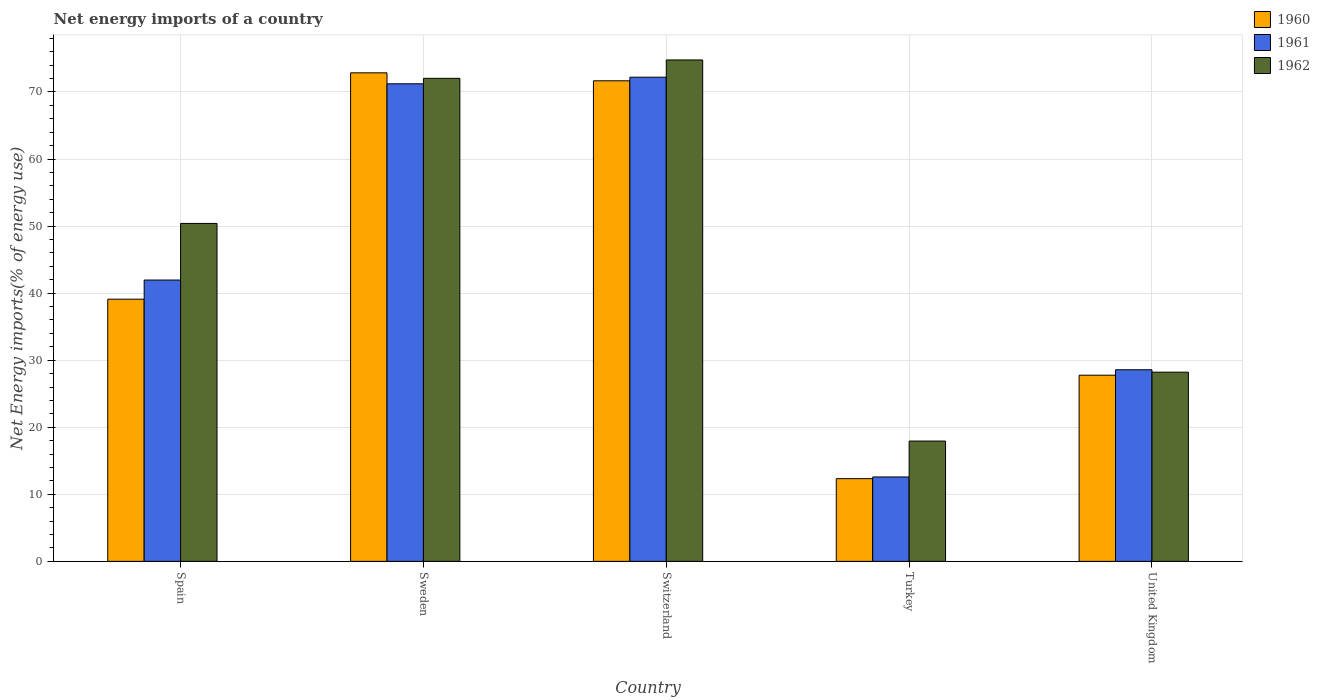Are the number of bars per tick equal to the number of legend labels?
Offer a very short reply. Yes. Are the number of bars on each tick of the X-axis equal?
Offer a very short reply. Yes. How many bars are there on the 3rd tick from the left?
Provide a succinct answer. 3. How many bars are there on the 5th tick from the right?
Give a very brief answer. 3. In how many cases, is the number of bars for a given country not equal to the number of legend labels?
Ensure brevity in your answer.  0. What is the net energy imports in 1961 in Sweden?
Your answer should be compact. 71.22. Across all countries, what is the maximum net energy imports in 1962?
Provide a short and direct response. 74.78. Across all countries, what is the minimum net energy imports in 1961?
Give a very brief answer. 12.59. In which country was the net energy imports in 1962 minimum?
Keep it short and to the point. Turkey. What is the total net energy imports in 1961 in the graph?
Your response must be concise. 226.55. What is the difference between the net energy imports in 1960 in Spain and that in Sweden?
Keep it short and to the point. -33.76. What is the difference between the net energy imports in 1962 in Sweden and the net energy imports in 1961 in Spain?
Your response must be concise. 30.08. What is the average net energy imports in 1961 per country?
Provide a succinct answer. 45.31. What is the difference between the net energy imports of/in 1961 and net energy imports of/in 1960 in United Kingdom?
Offer a terse response. 0.81. What is the ratio of the net energy imports in 1961 in Spain to that in Sweden?
Your answer should be compact. 0.59. What is the difference between the highest and the second highest net energy imports in 1960?
Provide a short and direct response. 33.76. What is the difference between the highest and the lowest net energy imports in 1961?
Your answer should be very brief. 59.62. In how many countries, is the net energy imports in 1960 greater than the average net energy imports in 1960 taken over all countries?
Make the answer very short. 2. How many bars are there?
Keep it short and to the point. 15. How many countries are there in the graph?
Your answer should be compact. 5. How are the legend labels stacked?
Provide a short and direct response. Vertical. What is the title of the graph?
Offer a terse response. Net energy imports of a country. What is the label or title of the X-axis?
Provide a short and direct response. Country. What is the label or title of the Y-axis?
Offer a very short reply. Net Energy imports(% of energy use). What is the Net Energy imports(% of energy use) in 1960 in Spain?
Offer a terse response. 39.1. What is the Net Energy imports(% of energy use) of 1961 in Spain?
Give a very brief answer. 41.95. What is the Net Energy imports(% of energy use) in 1962 in Spain?
Keep it short and to the point. 50.4. What is the Net Energy imports(% of energy use) of 1960 in Sweden?
Your answer should be very brief. 72.86. What is the Net Energy imports(% of energy use) of 1961 in Sweden?
Your response must be concise. 71.22. What is the Net Energy imports(% of energy use) in 1962 in Sweden?
Keep it short and to the point. 72.04. What is the Net Energy imports(% of energy use) in 1960 in Switzerland?
Give a very brief answer. 71.67. What is the Net Energy imports(% of energy use) in 1961 in Switzerland?
Offer a terse response. 72.21. What is the Net Energy imports(% of energy use) in 1962 in Switzerland?
Make the answer very short. 74.78. What is the Net Energy imports(% of energy use) of 1960 in Turkey?
Offer a terse response. 12.34. What is the Net Energy imports(% of energy use) of 1961 in Turkey?
Make the answer very short. 12.59. What is the Net Energy imports(% of energy use) in 1962 in Turkey?
Offer a very short reply. 17.94. What is the Net Energy imports(% of energy use) in 1960 in United Kingdom?
Keep it short and to the point. 27.76. What is the Net Energy imports(% of energy use) in 1961 in United Kingdom?
Ensure brevity in your answer.  28.58. What is the Net Energy imports(% of energy use) of 1962 in United Kingdom?
Give a very brief answer. 28.22. Across all countries, what is the maximum Net Energy imports(% of energy use) of 1960?
Ensure brevity in your answer.  72.86. Across all countries, what is the maximum Net Energy imports(% of energy use) of 1961?
Ensure brevity in your answer.  72.21. Across all countries, what is the maximum Net Energy imports(% of energy use) of 1962?
Provide a short and direct response. 74.78. Across all countries, what is the minimum Net Energy imports(% of energy use) in 1960?
Your answer should be very brief. 12.34. Across all countries, what is the minimum Net Energy imports(% of energy use) of 1961?
Give a very brief answer. 12.59. Across all countries, what is the minimum Net Energy imports(% of energy use) of 1962?
Make the answer very short. 17.94. What is the total Net Energy imports(% of energy use) of 1960 in the graph?
Give a very brief answer. 223.72. What is the total Net Energy imports(% of energy use) in 1961 in the graph?
Your answer should be compact. 226.55. What is the total Net Energy imports(% of energy use) in 1962 in the graph?
Ensure brevity in your answer.  243.37. What is the difference between the Net Energy imports(% of energy use) of 1960 in Spain and that in Sweden?
Your response must be concise. -33.76. What is the difference between the Net Energy imports(% of energy use) of 1961 in Spain and that in Sweden?
Keep it short and to the point. -29.27. What is the difference between the Net Energy imports(% of energy use) in 1962 in Spain and that in Sweden?
Your answer should be compact. -21.64. What is the difference between the Net Energy imports(% of energy use) of 1960 in Spain and that in Switzerland?
Your response must be concise. -32.57. What is the difference between the Net Energy imports(% of energy use) of 1961 in Spain and that in Switzerland?
Offer a very short reply. -30.25. What is the difference between the Net Energy imports(% of energy use) of 1962 in Spain and that in Switzerland?
Offer a terse response. -24.38. What is the difference between the Net Energy imports(% of energy use) of 1960 in Spain and that in Turkey?
Provide a short and direct response. 26.76. What is the difference between the Net Energy imports(% of energy use) in 1961 in Spain and that in Turkey?
Your answer should be compact. 29.37. What is the difference between the Net Energy imports(% of energy use) of 1962 in Spain and that in Turkey?
Offer a terse response. 32.46. What is the difference between the Net Energy imports(% of energy use) of 1960 in Spain and that in United Kingdom?
Your answer should be compact. 11.34. What is the difference between the Net Energy imports(% of energy use) of 1961 in Spain and that in United Kingdom?
Give a very brief answer. 13.38. What is the difference between the Net Energy imports(% of energy use) of 1962 in Spain and that in United Kingdom?
Make the answer very short. 22.18. What is the difference between the Net Energy imports(% of energy use) of 1960 in Sweden and that in Switzerland?
Provide a short and direct response. 1.19. What is the difference between the Net Energy imports(% of energy use) in 1961 in Sweden and that in Switzerland?
Offer a terse response. -0.98. What is the difference between the Net Energy imports(% of energy use) in 1962 in Sweden and that in Switzerland?
Offer a terse response. -2.74. What is the difference between the Net Energy imports(% of energy use) in 1960 in Sweden and that in Turkey?
Give a very brief answer. 60.52. What is the difference between the Net Energy imports(% of energy use) in 1961 in Sweden and that in Turkey?
Your response must be concise. 58.64. What is the difference between the Net Energy imports(% of energy use) of 1962 in Sweden and that in Turkey?
Your answer should be very brief. 54.1. What is the difference between the Net Energy imports(% of energy use) of 1960 in Sweden and that in United Kingdom?
Your response must be concise. 45.1. What is the difference between the Net Energy imports(% of energy use) of 1961 in Sweden and that in United Kingdom?
Offer a very short reply. 42.65. What is the difference between the Net Energy imports(% of energy use) in 1962 in Sweden and that in United Kingdom?
Keep it short and to the point. 43.82. What is the difference between the Net Energy imports(% of energy use) of 1960 in Switzerland and that in Turkey?
Provide a short and direct response. 59.33. What is the difference between the Net Energy imports(% of energy use) of 1961 in Switzerland and that in Turkey?
Provide a succinct answer. 59.62. What is the difference between the Net Energy imports(% of energy use) in 1962 in Switzerland and that in Turkey?
Your answer should be compact. 56.84. What is the difference between the Net Energy imports(% of energy use) in 1960 in Switzerland and that in United Kingdom?
Your response must be concise. 43.91. What is the difference between the Net Energy imports(% of energy use) in 1961 in Switzerland and that in United Kingdom?
Your answer should be compact. 43.63. What is the difference between the Net Energy imports(% of energy use) in 1962 in Switzerland and that in United Kingdom?
Your answer should be compact. 46.56. What is the difference between the Net Energy imports(% of energy use) of 1960 in Turkey and that in United Kingdom?
Offer a terse response. -15.43. What is the difference between the Net Energy imports(% of energy use) of 1961 in Turkey and that in United Kingdom?
Keep it short and to the point. -15.99. What is the difference between the Net Energy imports(% of energy use) in 1962 in Turkey and that in United Kingdom?
Offer a terse response. -10.27. What is the difference between the Net Energy imports(% of energy use) of 1960 in Spain and the Net Energy imports(% of energy use) of 1961 in Sweden?
Offer a very short reply. -32.12. What is the difference between the Net Energy imports(% of energy use) of 1960 in Spain and the Net Energy imports(% of energy use) of 1962 in Sweden?
Provide a short and direct response. -32.94. What is the difference between the Net Energy imports(% of energy use) in 1961 in Spain and the Net Energy imports(% of energy use) in 1962 in Sweden?
Offer a terse response. -30.08. What is the difference between the Net Energy imports(% of energy use) in 1960 in Spain and the Net Energy imports(% of energy use) in 1961 in Switzerland?
Provide a succinct answer. -33.11. What is the difference between the Net Energy imports(% of energy use) of 1960 in Spain and the Net Energy imports(% of energy use) of 1962 in Switzerland?
Ensure brevity in your answer.  -35.68. What is the difference between the Net Energy imports(% of energy use) in 1961 in Spain and the Net Energy imports(% of energy use) in 1962 in Switzerland?
Your answer should be very brief. -32.82. What is the difference between the Net Energy imports(% of energy use) of 1960 in Spain and the Net Energy imports(% of energy use) of 1961 in Turkey?
Your answer should be compact. 26.51. What is the difference between the Net Energy imports(% of energy use) in 1960 in Spain and the Net Energy imports(% of energy use) in 1962 in Turkey?
Your answer should be compact. 21.16. What is the difference between the Net Energy imports(% of energy use) in 1961 in Spain and the Net Energy imports(% of energy use) in 1962 in Turkey?
Provide a succinct answer. 24.01. What is the difference between the Net Energy imports(% of energy use) in 1960 in Spain and the Net Energy imports(% of energy use) in 1961 in United Kingdom?
Provide a succinct answer. 10.53. What is the difference between the Net Energy imports(% of energy use) of 1960 in Spain and the Net Energy imports(% of energy use) of 1962 in United Kingdom?
Offer a terse response. 10.88. What is the difference between the Net Energy imports(% of energy use) of 1961 in Spain and the Net Energy imports(% of energy use) of 1962 in United Kingdom?
Provide a short and direct response. 13.74. What is the difference between the Net Energy imports(% of energy use) of 1960 in Sweden and the Net Energy imports(% of energy use) of 1961 in Switzerland?
Your answer should be compact. 0.65. What is the difference between the Net Energy imports(% of energy use) in 1960 in Sweden and the Net Energy imports(% of energy use) in 1962 in Switzerland?
Provide a short and direct response. -1.92. What is the difference between the Net Energy imports(% of energy use) in 1961 in Sweden and the Net Energy imports(% of energy use) in 1962 in Switzerland?
Make the answer very short. -3.56. What is the difference between the Net Energy imports(% of energy use) of 1960 in Sweden and the Net Energy imports(% of energy use) of 1961 in Turkey?
Your response must be concise. 60.27. What is the difference between the Net Energy imports(% of energy use) of 1960 in Sweden and the Net Energy imports(% of energy use) of 1962 in Turkey?
Offer a very short reply. 54.92. What is the difference between the Net Energy imports(% of energy use) in 1961 in Sweden and the Net Energy imports(% of energy use) in 1962 in Turkey?
Give a very brief answer. 53.28. What is the difference between the Net Energy imports(% of energy use) of 1960 in Sweden and the Net Energy imports(% of energy use) of 1961 in United Kingdom?
Give a very brief answer. 44.28. What is the difference between the Net Energy imports(% of energy use) of 1960 in Sweden and the Net Energy imports(% of energy use) of 1962 in United Kingdom?
Offer a terse response. 44.64. What is the difference between the Net Energy imports(% of energy use) in 1961 in Sweden and the Net Energy imports(% of energy use) in 1962 in United Kingdom?
Provide a short and direct response. 43.01. What is the difference between the Net Energy imports(% of energy use) in 1960 in Switzerland and the Net Energy imports(% of energy use) in 1961 in Turkey?
Make the answer very short. 59.08. What is the difference between the Net Energy imports(% of energy use) in 1960 in Switzerland and the Net Energy imports(% of energy use) in 1962 in Turkey?
Your answer should be compact. 53.73. What is the difference between the Net Energy imports(% of energy use) of 1961 in Switzerland and the Net Energy imports(% of energy use) of 1962 in Turkey?
Provide a short and direct response. 54.26. What is the difference between the Net Energy imports(% of energy use) in 1960 in Switzerland and the Net Energy imports(% of energy use) in 1961 in United Kingdom?
Offer a very short reply. 43.09. What is the difference between the Net Energy imports(% of energy use) of 1960 in Switzerland and the Net Energy imports(% of energy use) of 1962 in United Kingdom?
Make the answer very short. 43.45. What is the difference between the Net Energy imports(% of energy use) in 1961 in Switzerland and the Net Energy imports(% of energy use) in 1962 in United Kingdom?
Provide a succinct answer. 43.99. What is the difference between the Net Energy imports(% of energy use) in 1960 in Turkey and the Net Energy imports(% of energy use) in 1961 in United Kingdom?
Provide a short and direct response. -16.24. What is the difference between the Net Energy imports(% of energy use) of 1960 in Turkey and the Net Energy imports(% of energy use) of 1962 in United Kingdom?
Provide a short and direct response. -15.88. What is the difference between the Net Energy imports(% of energy use) of 1961 in Turkey and the Net Energy imports(% of energy use) of 1962 in United Kingdom?
Provide a succinct answer. -15.63. What is the average Net Energy imports(% of energy use) in 1960 per country?
Ensure brevity in your answer.  44.74. What is the average Net Energy imports(% of energy use) of 1961 per country?
Ensure brevity in your answer.  45.31. What is the average Net Energy imports(% of energy use) of 1962 per country?
Offer a terse response. 48.67. What is the difference between the Net Energy imports(% of energy use) of 1960 and Net Energy imports(% of energy use) of 1961 in Spain?
Your response must be concise. -2.85. What is the difference between the Net Energy imports(% of energy use) of 1960 and Net Energy imports(% of energy use) of 1962 in Spain?
Make the answer very short. -11.3. What is the difference between the Net Energy imports(% of energy use) in 1961 and Net Energy imports(% of energy use) in 1962 in Spain?
Offer a very short reply. -8.44. What is the difference between the Net Energy imports(% of energy use) of 1960 and Net Energy imports(% of energy use) of 1961 in Sweden?
Your answer should be very brief. 1.63. What is the difference between the Net Energy imports(% of energy use) in 1960 and Net Energy imports(% of energy use) in 1962 in Sweden?
Offer a very short reply. 0.82. What is the difference between the Net Energy imports(% of energy use) in 1961 and Net Energy imports(% of energy use) in 1962 in Sweden?
Your response must be concise. -0.81. What is the difference between the Net Energy imports(% of energy use) in 1960 and Net Energy imports(% of energy use) in 1961 in Switzerland?
Provide a succinct answer. -0.54. What is the difference between the Net Energy imports(% of energy use) of 1960 and Net Energy imports(% of energy use) of 1962 in Switzerland?
Provide a short and direct response. -3.11. What is the difference between the Net Energy imports(% of energy use) in 1961 and Net Energy imports(% of energy use) in 1962 in Switzerland?
Offer a very short reply. -2.57. What is the difference between the Net Energy imports(% of energy use) of 1960 and Net Energy imports(% of energy use) of 1961 in Turkey?
Give a very brief answer. -0.25. What is the difference between the Net Energy imports(% of energy use) of 1960 and Net Energy imports(% of energy use) of 1962 in Turkey?
Provide a short and direct response. -5.61. What is the difference between the Net Energy imports(% of energy use) of 1961 and Net Energy imports(% of energy use) of 1962 in Turkey?
Provide a short and direct response. -5.36. What is the difference between the Net Energy imports(% of energy use) in 1960 and Net Energy imports(% of energy use) in 1961 in United Kingdom?
Provide a succinct answer. -0.81. What is the difference between the Net Energy imports(% of energy use) in 1960 and Net Energy imports(% of energy use) in 1962 in United Kingdom?
Give a very brief answer. -0.45. What is the difference between the Net Energy imports(% of energy use) of 1961 and Net Energy imports(% of energy use) of 1962 in United Kingdom?
Provide a succinct answer. 0.36. What is the ratio of the Net Energy imports(% of energy use) of 1960 in Spain to that in Sweden?
Make the answer very short. 0.54. What is the ratio of the Net Energy imports(% of energy use) in 1961 in Spain to that in Sweden?
Your answer should be compact. 0.59. What is the ratio of the Net Energy imports(% of energy use) in 1962 in Spain to that in Sweden?
Make the answer very short. 0.7. What is the ratio of the Net Energy imports(% of energy use) in 1960 in Spain to that in Switzerland?
Offer a terse response. 0.55. What is the ratio of the Net Energy imports(% of energy use) in 1961 in Spain to that in Switzerland?
Your answer should be very brief. 0.58. What is the ratio of the Net Energy imports(% of energy use) in 1962 in Spain to that in Switzerland?
Provide a succinct answer. 0.67. What is the ratio of the Net Energy imports(% of energy use) of 1960 in Spain to that in Turkey?
Your response must be concise. 3.17. What is the ratio of the Net Energy imports(% of energy use) in 1961 in Spain to that in Turkey?
Your answer should be compact. 3.33. What is the ratio of the Net Energy imports(% of energy use) in 1962 in Spain to that in Turkey?
Provide a short and direct response. 2.81. What is the ratio of the Net Energy imports(% of energy use) in 1960 in Spain to that in United Kingdom?
Your answer should be very brief. 1.41. What is the ratio of the Net Energy imports(% of energy use) in 1961 in Spain to that in United Kingdom?
Your answer should be very brief. 1.47. What is the ratio of the Net Energy imports(% of energy use) in 1962 in Spain to that in United Kingdom?
Give a very brief answer. 1.79. What is the ratio of the Net Energy imports(% of energy use) of 1960 in Sweden to that in Switzerland?
Offer a very short reply. 1.02. What is the ratio of the Net Energy imports(% of energy use) of 1961 in Sweden to that in Switzerland?
Keep it short and to the point. 0.99. What is the ratio of the Net Energy imports(% of energy use) in 1962 in Sweden to that in Switzerland?
Provide a short and direct response. 0.96. What is the ratio of the Net Energy imports(% of energy use) of 1960 in Sweden to that in Turkey?
Offer a very short reply. 5.91. What is the ratio of the Net Energy imports(% of energy use) of 1961 in Sweden to that in Turkey?
Make the answer very short. 5.66. What is the ratio of the Net Energy imports(% of energy use) in 1962 in Sweden to that in Turkey?
Provide a succinct answer. 4.02. What is the ratio of the Net Energy imports(% of energy use) in 1960 in Sweden to that in United Kingdom?
Offer a very short reply. 2.62. What is the ratio of the Net Energy imports(% of energy use) of 1961 in Sweden to that in United Kingdom?
Give a very brief answer. 2.49. What is the ratio of the Net Energy imports(% of energy use) of 1962 in Sweden to that in United Kingdom?
Your response must be concise. 2.55. What is the ratio of the Net Energy imports(% of energy use) of 1960 in Switzerland to that in Turkey?
Provide a succinct answer. 5.81. What is the ratio of the Net Energy imports(% of energy use) of 1961 in Switzerland to that in Turkey?
Give a very brief answer. 5.74. What is the ratio of the Net Energy imports(% of energy use) in 1962 in Switzerland to that in Turkey?
Make the answer very short. 4.17. What is the ratio of the Net Energy imports(% of energy use) of 1960 in Switzerland to that in United Kingdom?
Ensure brevity in your answer.  2.58. What is the ratio of the Net Energy imports(% of energy use) of 1961 in Switzerland to that in United Kingdom?
Provide a short and direct response. 2.53. What is the ratio of the Net Energy imports(% of energy use) in 1962 in Switzerland to that in United Kingdom?
Offer a terse response. 2.65. What is the ratio of the Net Energy imports(% of energy use) in 1960 in Turkey to that in United Kingdom?
Your answer should be compact. 0.44. What is the ratio of the Net Energy imports(% of energy use) in 1961 in Turkey to that in United Kingdom?
Your answer should be very brief. 0.44. What is the ratio of the Net Energy imports(% of energy use) in 1962 in Turkey to that in United Kingdom?
Your answer should be compact. 0.64. What is the difference between the highest and the second highest Net Energy imports(% of energy use) in 1960?
Offer a terse response. 1.19. What is the difference between the highest and the second highest Net Energy imports(% of energy use) of 1961?
Your answer should be very brief. 0.98. What is the difference between the highest and the second highest Net Energy imports(% of energy use) in 1962?
Provide a short and direct response. 2.74. What is the difference between the highest and the lowest Net Energy imports(% of energy use) in 1960?
Ensure brevity in your answer.  60.52. What is the difference between the highest and the lowest Net Energy imports(% of energy use) of 1961?
Ensure brevity in your answer.  59.62. What is the difference between the highest and the lowest Net Energy imports(% of energy use) in 1962?
Keep it short and to the point. 56.84. 